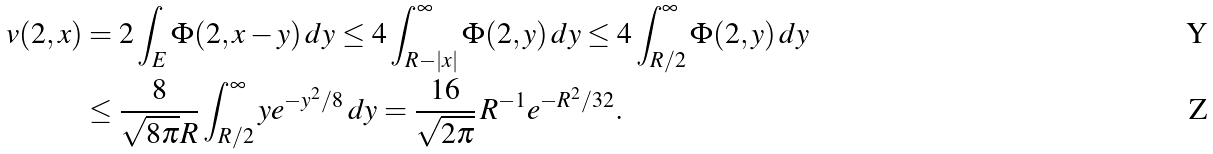<formula> <loc_0><loc_0><loc_500><loc_500>v ( 2 , x ) & = 2 \int _ { E } \Phi ( 2 , x - y ) \, d y \leq 4 \int _ { R - | x | } ^ { \infty } \Phi ( 2 , y ) \, d y \leq 4 \int _ { R / 2 } ^ { \infty } \Phi ( 2 , y ) \, d y \\ & \leq \frac { 8 } { \sqrt { 8 \pi } R } \int _ { R / 2 } ^ { \infty } y e ^ { - y ^ { 2 } / 8 } \, d y = \frac { 1 6 } { \sqrt { 2 \pi } } \, R ^ { - 1 } e ^ { - R ^ { 2 } / 3 2 } .</formula> 